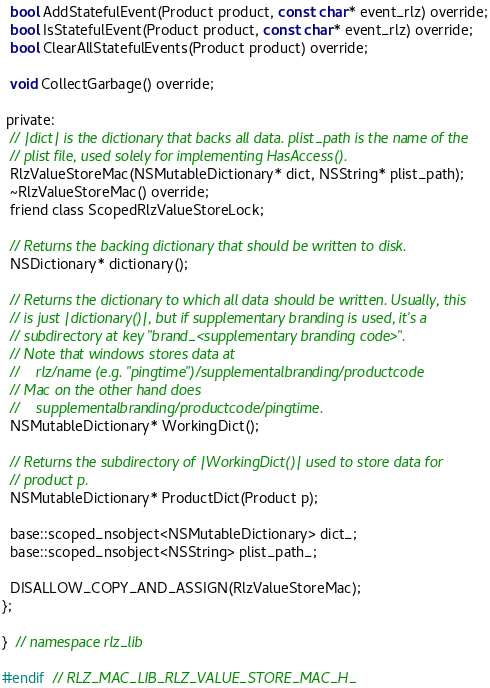<code> <loc_0><loc_0><loc_500><loc_500><_C_>  bool AddStatefulEvent(Product product, const char* event_rlz) override;
  bool IsStatefulEvent(Product product, const char* event_rlz) override;
  bool ClearAllStatefulEvents(Product product) override;

  void CollectGarbage() override;

 private:
  // |dict| is the dictionary that backs all data. plist_path is the name of the
  // plist file, used solely for implementing HasAccess().
  RlzValueStoreMac(NSMutableDictionary* dict, NSString* plist_path);
  ~RlzValueStoreMac() override;
  friend class ScopedRlzValueStoreLock;

  // Returns the backing dictionary that should be written to disk.
  NSDictionary* dictionary();

  // Returns the dictionary to which all data should be written. Usually, this
  // is just |dictionary()|, but if supplementary branding is used, it's a
  // subdirectory at key "brand_<supplementary branding code>".
  // Note that windows stores data at
  //    rlz/name (e.g. "pingtime")/supplementalbranding/productcode
  // Mac on the other hand does
  //    supplementalbranding/productcode/pingtime.
  NSMutableDictionary* WorkingDict();

  // Returns the subdirectory of |WorkingDict()| used to store data for
  // product p.
  NSMutableDictionary* ProductDict(Product p);

  base::scoped_nsobject<NSMutableDictionary> dict_;
  base::scoped_nsobject<NSString> plist_path_;

  DISALLOW_COPY_AND_ASSIGN(RlzValueStoreMac);
};

}  // namespace rlz_lib

#endif  // RLZ_MAC_LIB_RLZ_VALUE_STORE_MAC_H_
</code> 